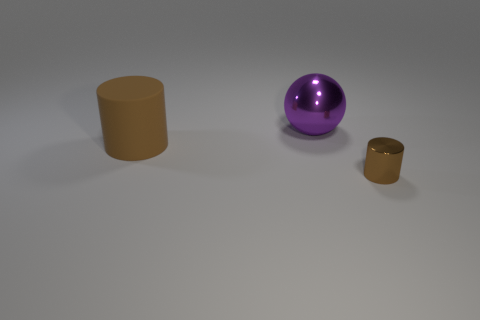Add 3 small brown shiny cylinders. How many objects exist? 6 Subtract all cylinders. How many objects are left? 1 Subtract 0 yellow cylinders. How many objects are left? 3 Subtract all yellow spheres. Subtract all cyan cylinders. How many spheres are left? 1 Subtract all purple balls. How many red cylinders are left? 0 Subtract all rubber balls. Subtract all tiny brown metal objects. How many objects are left? 2 Add 2 large shiny balls. How many large shiny balls are left? 3 Add 2 brown cylinders. How many brown cylinders exist? 4 